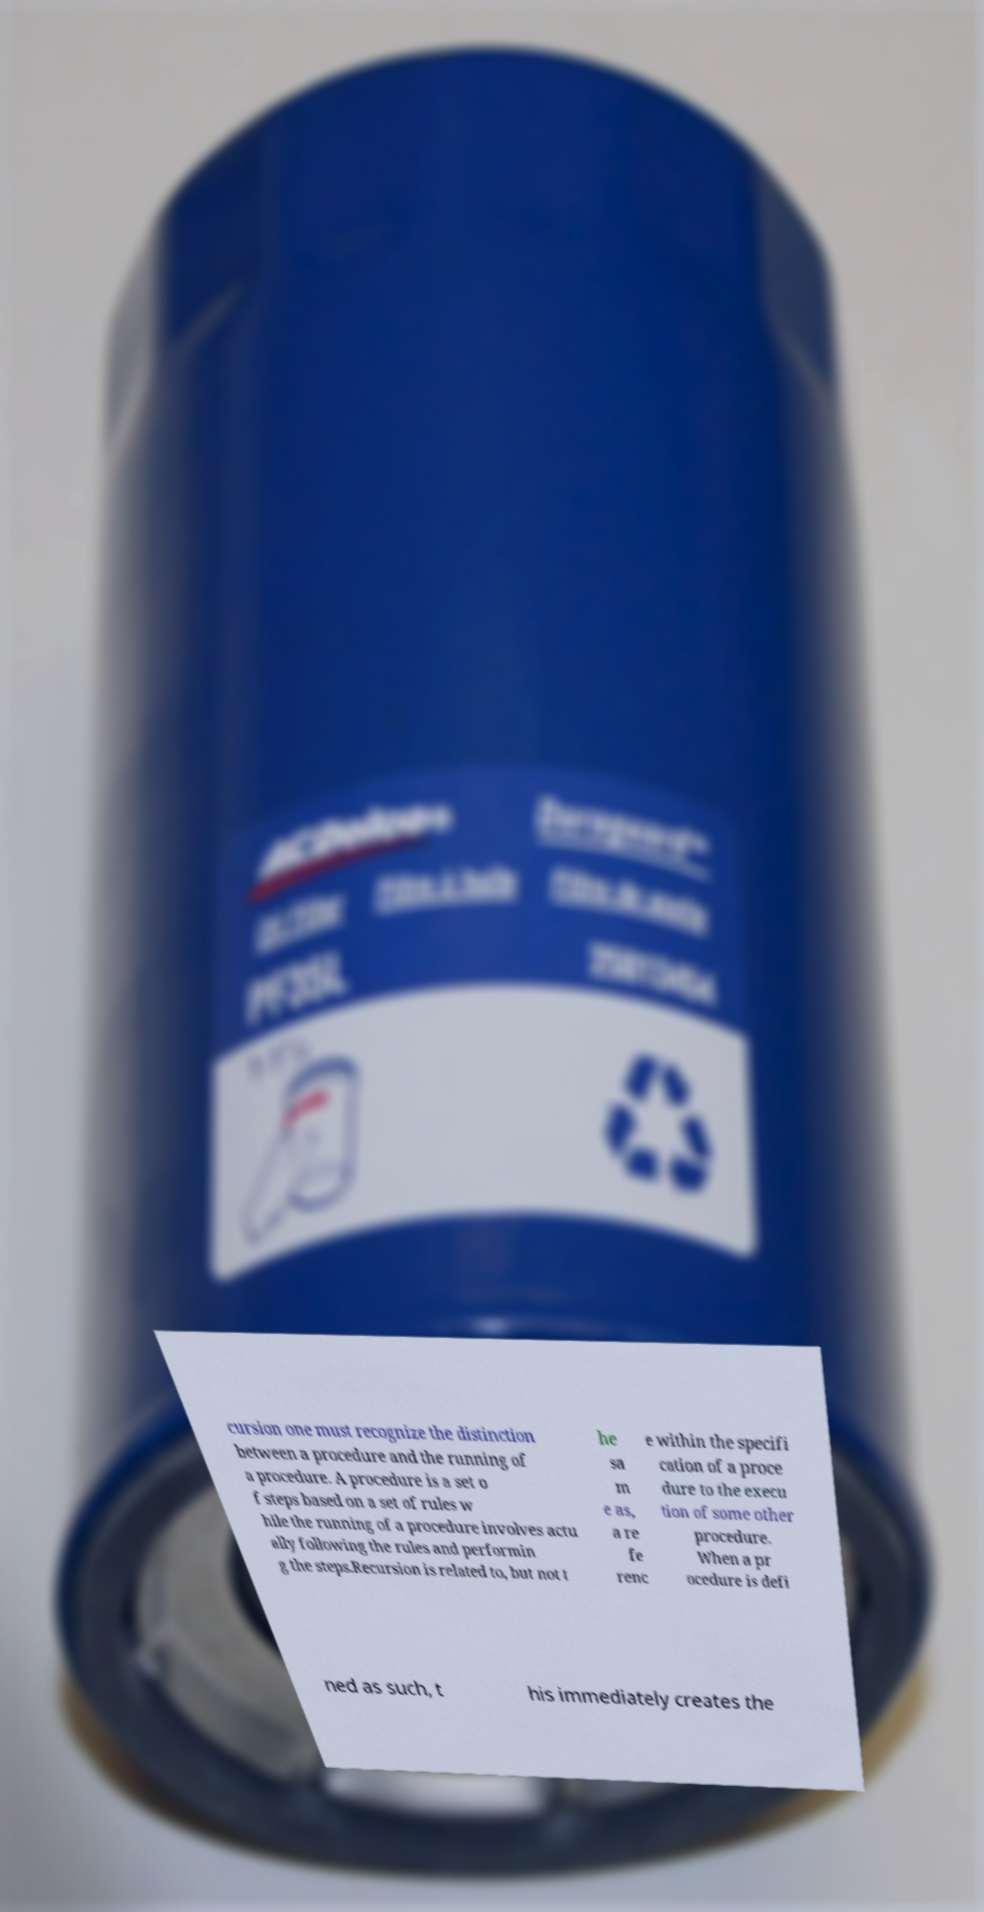There's text embedded in this image that I need extracted. Can you transcribe it verbatim? cursion one must recognize the distinction between a procedure and the running of a procedure. A procedure is a set o f steps based on a set of rules w hile the running of a procedure involves actu ally following the rules and performin g the steps.Recursion is related to, but not t he sa m e as, a re fe renc e within the specifi cation of a proce dure to the execu tion of some other procedure. When a pr ocedure is defi ned as such, t his immediately creates the 